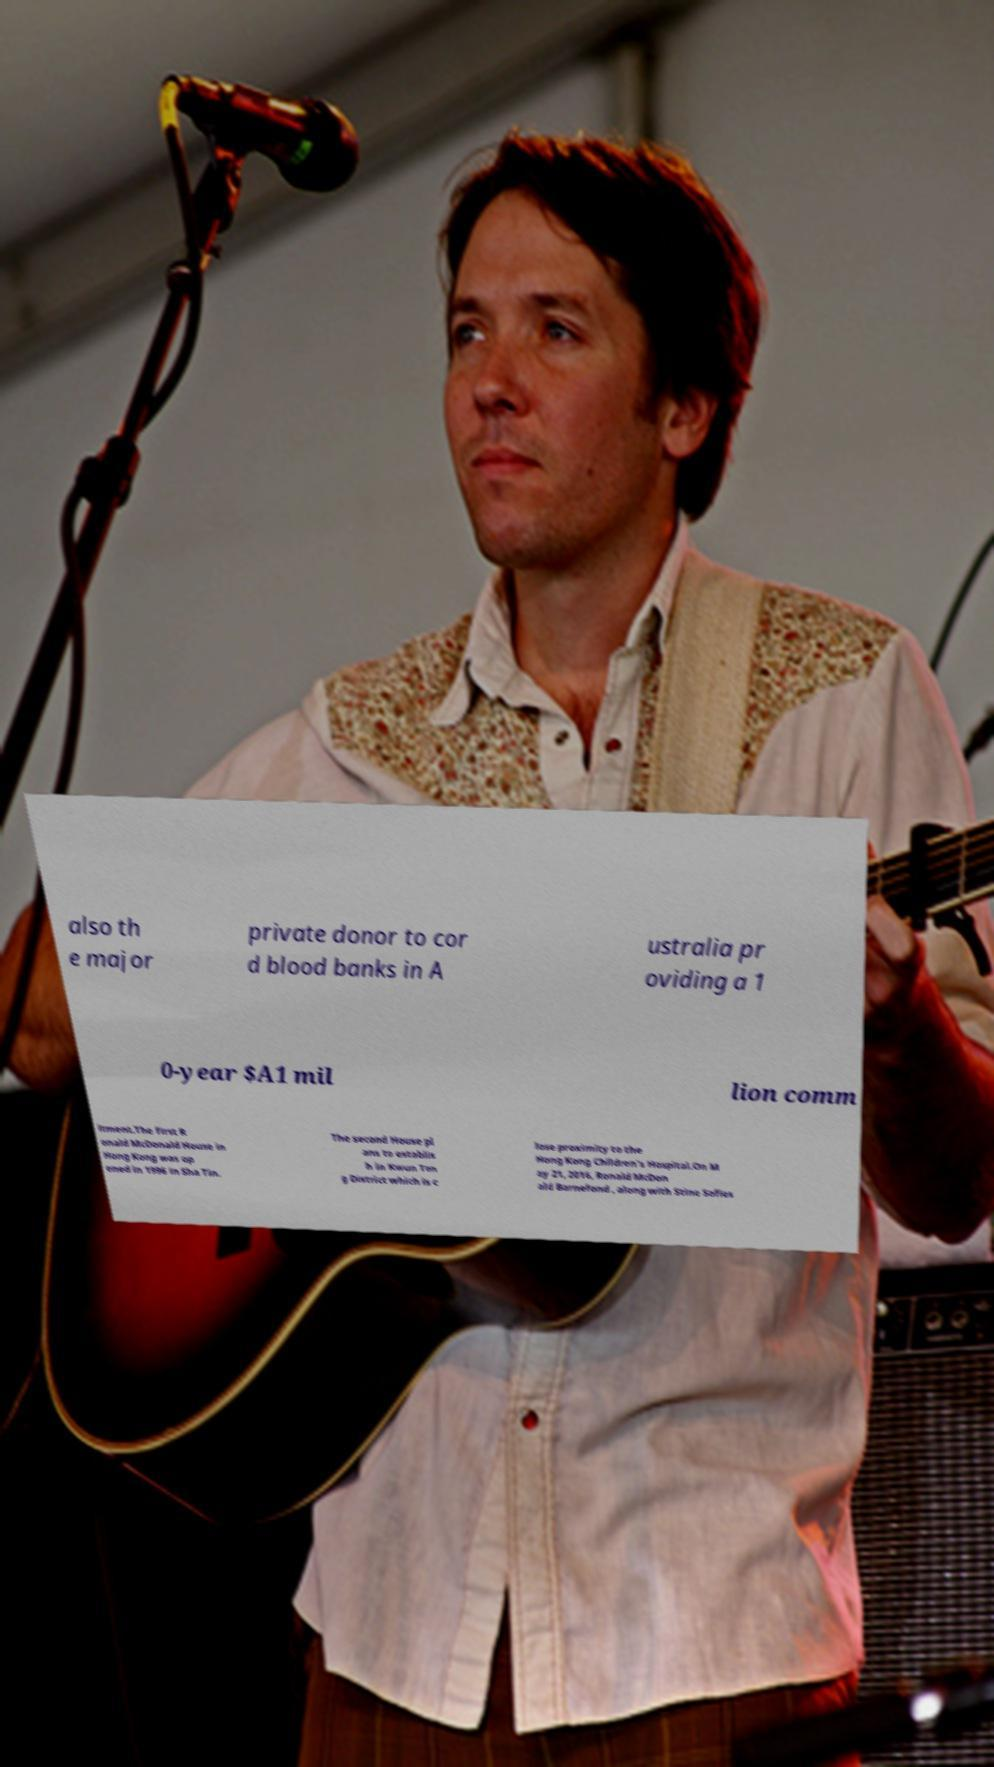Can you accurately transcribe the text from the provided image for me? also th e major private donor to cor d blood banks in A ustralia pr oviding a 1 0-year $A1 mil lion comm itment.The first R onald McDonald House in Hong Kong was op ened in 1996 in Sha Tin. The second House pl ans to establis h in Kwun Ton g District which is c lose proximity to the Hong Kong Children's Hospital.On M ay 21, 2016, Ronald McDon ald Barnefond , along with Stine Sofies 